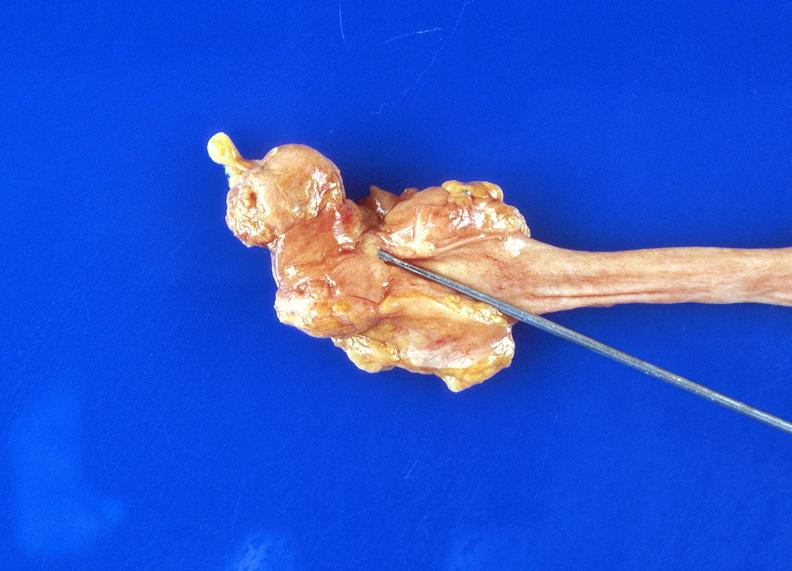does this image show ureteral stricture?
Answer the question using a single word or phrase. Yes 